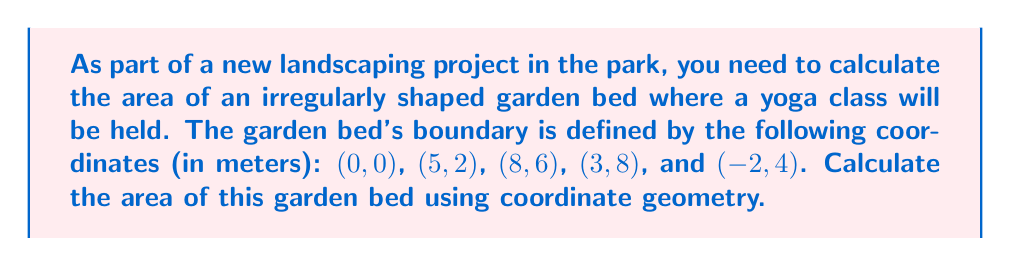Help me with this question. To calculate the area of this irregularly shaped garden bed, we can use the Shoelace formula (also known as the surveyor's formula). This method works for any polygon given its vertices.

The formula is:

$$ A = \frac{1}{2}\left|\sum_{i=1}^{n-1} (x_i y_{i+1} - x_{i+1} y_i) + (x_n y_1 - x_1 y_n)\right| $$

Where $(x_i, y_i)$ are the coordinates of the $i$-th vertex, and $n$ is the total number of vertices.

Let's apply this formula to our garden bed:

1) First, let's list our coordinates in order:
   $(x_1, y_1) = (0, 0)$
   $(x_2, y_2) = (5, 2)$
   $(x_3, y_3) = (8, 6)$
   $(x_4, y_4) = (3, 8)$
   $(x_5, y_5) = (-2, 4)$

2) Now, let's calculate each term in the sum:
   $(0 \cdot 2) - (5 \cdot 0) = 0 - 0 = 0$
   $(5 \cdot 6) - (8 \cdot 2) = 30 - 16 = 14$
   $(8 \cdot 8) - (3 \cdot 6) = 64 - 18 = 46$
   $(3 \cdot 4) - (-2 \cdot 8) = 12 + 16 = 28$
   $(-2 \cdot 0) - (0 \cdot 4) = 0 - 0 = 0$

3) Sum these terms:
   $0 + 14 + 46 + 28 + 0 = 88$

4) Multiply by $\frac{1}{2}$:
   $\frac{1}{2} \cdot 88 = 44$

Therefore, the area of the garden bed is 44 square meters.
Answer: 44 m² 